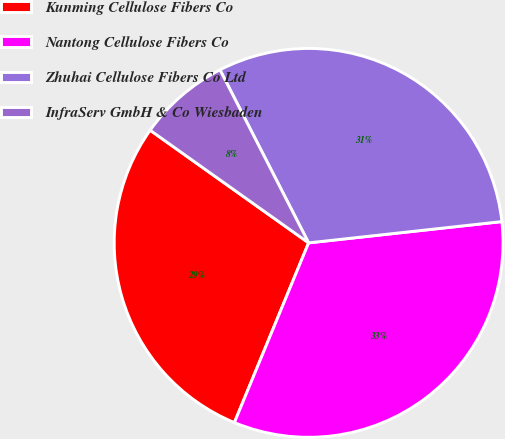<chart> <loc_0><loc_0><loc_500><loc_500><pie_chart><fcel>Kunming Cellulose Fibers Co<fcel>Nantong Cellulose Fibers Co<fcel>Zhuhai Cellulose Fibers Co Ltd<fcel>InfraServ GmbH & Co Wiesbaden<nl><fcel>28.6%<fcel>32.98%<fcel>30.79%<fcel>7.63%<nl></chart> 